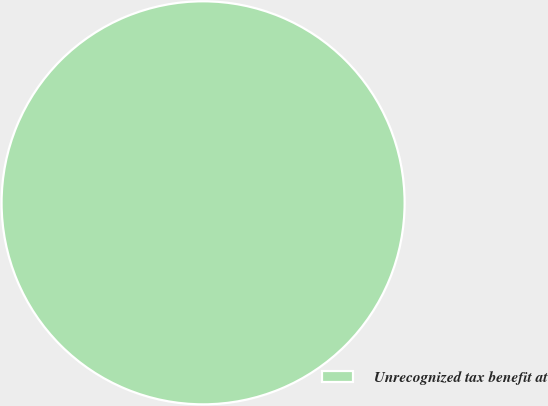Convert chart to OTSL. <chart><loc_0><loc_0><loc_500><loc_500><pie_chart><fcel>Unrecognized tax benefit at<nl><fcel>100.0%<nl></chart> 